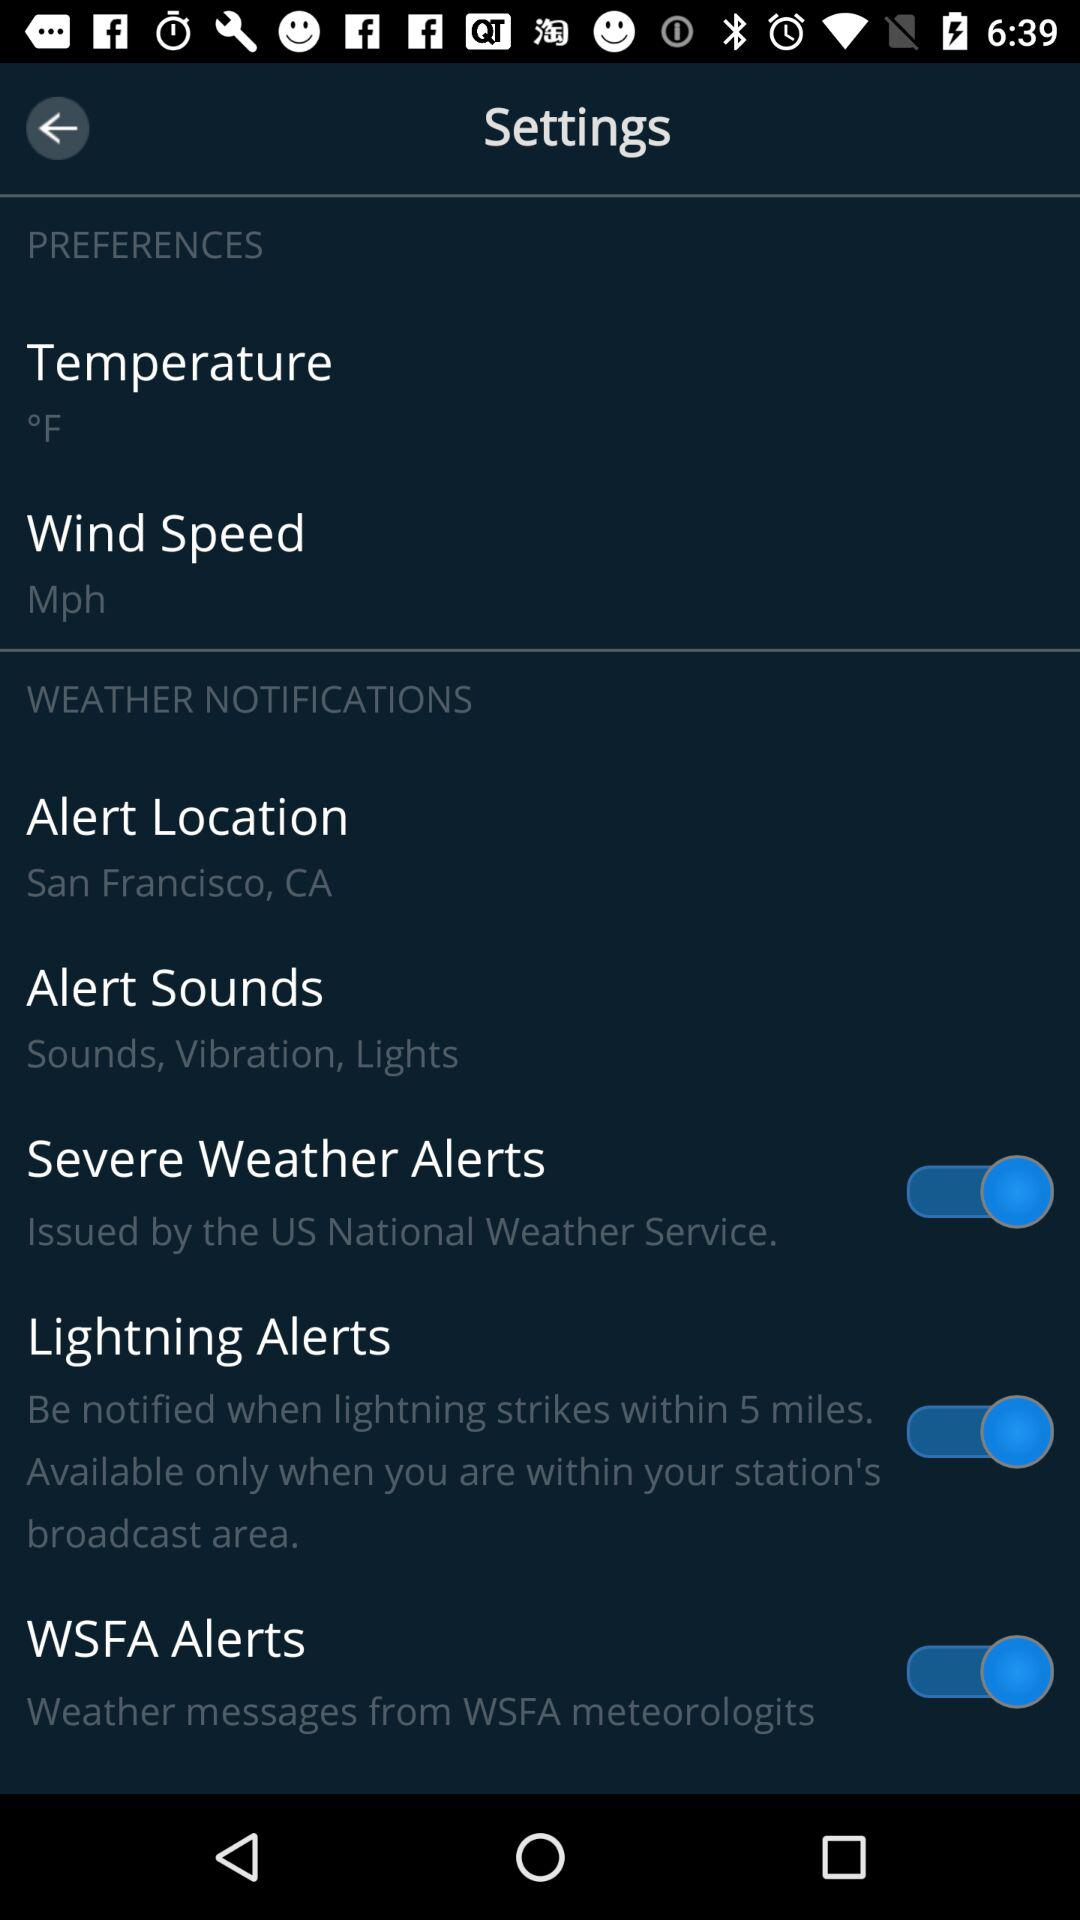Which unit is given for wind speed? The given unit of wind speed is miles per hour. 